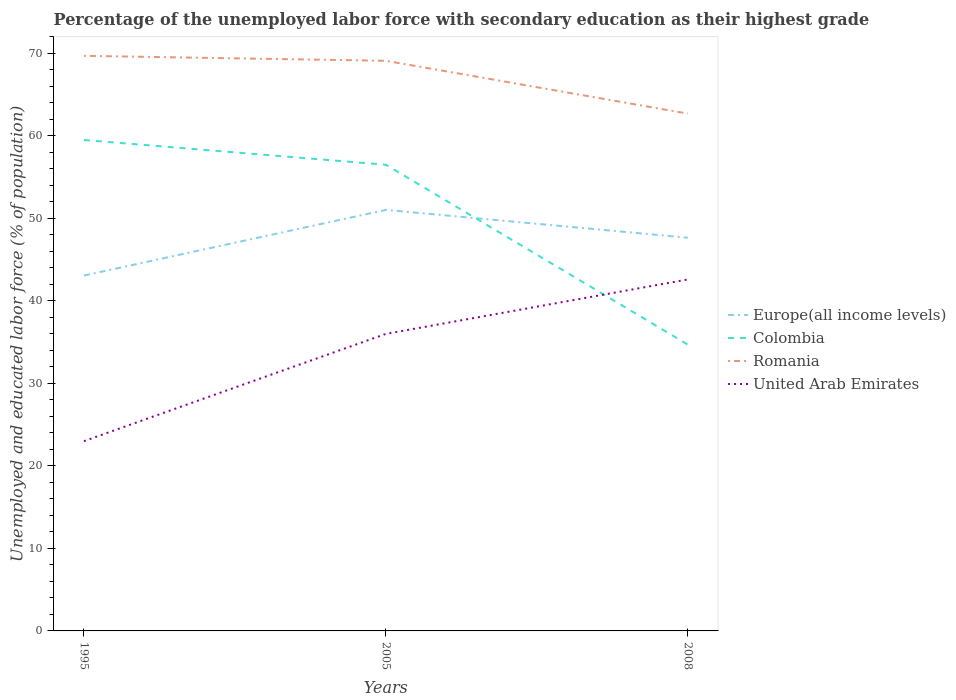How many different coloured lines are there?
Offer a very short reply. 4. Across all years, what is the maximum percentage of the unemployed labor force with secondary education in Romania?
Keep it short and to the point. 62.7. What is the total percentage of the unemployed labor force with secondary education in Colombia in the graph?
Your answer should be compact. 24.8. What is the difference between the highest and the second highest percentage of the unemployed labor force with secondary education in Romania?
Ensure brevity in your answer.  7. What is the difference between the highest and the lowest percentage of the unemployed labor force with secondary education in Colombia?
Your response must be concise. 2. Is the percentage of the unemployed labor force with secondary education in Europe(all income levels) strictly greater than the percentage of the unemployed labor force with secondary education in Romania over the years?
Provide a short and direct response. Yes. How many lines are there?
Provide a succinct answer. 4. How many years are there in the graph?
Ensure brevity in your answer.  3. Are the values on the major ticks of Y-axis written in scientific E-notation?
Give a very brief answer. No. Does the graph contain grids?
Your answer should be very brief. No. How many legend labels are there?
Make the answer very short. 4. What is the title of the graph?
Provide a succinct answer. Percentage of the unemployed labor force with secondary education as their highest grade. What is the label or title of the Y-axis?
Offer a very short reply. Unemployed and educated labor force (% of population). What is the Unemployed and educated labor force (% of population) in Europe(all income levels) in 1995?
Your response must be concise. 43.07. What is the Unemployed and educated labor force (% of population) of Colombia in 1995?
Provide a succinct answer. 59.5. What is the Unemployed and educated labor force (% of population) of Romania in 1995?
Your response must be concise. 69.7. What is the Unemployed and educated labor force (% of population) in Europe(all income levels) in 2005?
Make the answer very short. 51.03. What is the Unemployed and educated labor force (% of population) in Colombia in 2005?
Ensure brevity in your answer.  56.5. What is the Unemployed and educated labor force (% of population) of Romania in 2005?
Your answer should be very brief. 69.1. What is the Unemployed and educated labor force (% of population) of United Arab Emirates in 2005?
Offer a very short reply. 36. What is the Unemployed and educated labor force (% of population) of Europe(all income levels) in 2008?
Provide a short and direct response. 47.66. What is the Unemployed and educated labor force (% of population) of Colombia in 2008?
Your response must be concise. 34.7. What is the Unemployed and educated labor force (% of population) of Romania in 2008?
Provide a succinct answer. 62.7. What is the Unemployed and educated labor force (% of population) in United Arab Emirates in 2008?
Give a very brief answer. 42.6. Across all years, what is the maximum Unemployed and educated labor force (% of population) in Europe(all income levels)?
Ensure brevity in your answer.  51.03. Across all years, what is the maximum Unemployed and educated labor force (% of population) in Colombia?
Make the answer very short. 59.5. Across all years, what is the maximum Unemployed and educated labor force (% of population) in Romania?
Provide a short and direct response. 69.7. Across all years, what is the maximum Unemployed and educated labor force (% of population) in United Arab Emirates?
Offer a very short reply. 42.6. Across all years, what is the minimum Unemployed and educated labor force (% of population) in Europe(all income levels)?
Your answer should be compact. 43.07. Across all years, what is the minimum Unemployed and educated labor force (% of population) of Colombia?
Your response must be concise. 34.7. Across all years, what is the minimum Unemployed and educated labor force (% of population) in Romania?
Provide a succinct answer. 62.7. What is the total Unemployed and educated labor force (% of population) of Europe(all income levels) in the graph?
Make the answer very short. 141.76. What is the total Unemployed and educated labor force (% of population) of Colombia in the graph?
Your answer should be compact. 150.7. What is the total Unemployed and educated labor force (% of population) of Romania in the graph?
Keep it short and to the point. 201.5. What is the total Unemployed and educated labor force (% of population) of United Arab Emirates in the graph?
Keep it short and to the point. 101.6. What is the difference between the Unemployed and educated labor force (% of population) of Europe(all income levels) in 1995 and that in 2005?
Your answer should be compact. -7.95. What is the difference between the Unemployed and educated labor force (% of population) in Europe(all income levels) in 1995 and that in 2008?
Ensure brevity in your answer.  -4.58. What is the difference between the Unemployed and educated labor force (% of population) of Colombia in 1995 and that in 2008?
Keep it short and to the point. 24.8. What is the difference between the Unemployed and educated labor force (% of population) of United Arab Emirates in 1995 and that in 2008?
Give a very brief answer. -19.6. What is the difference between the Unemployed and educated labor force (% of population) in Europe(all income levels) in 2005 and that in 2008?
Keep it short and to the point. 3.37. What is the difference between the Unemployed and educated labor force (% of population) in Colombia in 2005 and that in 2008?
Ensure brevity in your answer.  21.8. What is the difference between the Unemployed and educated labor force (% of population) of Romania in 2005 and that in 2008?
Keep it short and to the point. 6.4. What is the difference between the Unemployed and educated labor force (% of population) in United Arab Emirates in 2005 and that in 2008?
Ensure brevity in your answer.  -6.6. What is the difference between the Unemployed and educated labor force (% of population) in Europe(all income levels) in 1995 and the Unemployed and educated labor force (% of population) in Colombia in 2005?
Ensure brevity in your answer.  -13.43. What is the difference between the Unemployed and educated labor force (% of population) in Europe(all income levels) in 1995 and the Unemployed and educated labor force (% of population) in Romania in 2005?
Offer a very short reply. -26.03. What is the difference between the Unemployed and educated labor force (% of population) in Europe(all income levels) in 1995 and the Unemployed and educated labor force (% of population) in United Arab Emirates in 2005?
Your answer should be very brief. 7.07. What is the difference between the Unemployed and educated labor force (% of population) in Colombia in 1995 and the Unemployed and educated labor force (% of population) in United Arab Emirates in 2005?
Provide a succinct answer. 23.5. What is the difference between the Unemployed and educated labor force (% of population) of Romania in 1995 and the Unemployed and educated labor force (% of population) of United Arab Emirates in 2005?
Give a very brief answer. 33.7. What is the difference between the Unemployed and educated labor force (% of population) in Europe(all income levels) in 1995 and the Unemployed and educated labor force (% of population) in Colombia in 2008?
Provide a short and direct response. 8.37. What is the difference between the Unemployed and educated labor force (% of population) of Europe(all income levels) in 1995 and the Unemployed and educated labor force (% of population) of Romania in 2008?
Ensure brevity in your answer.  -19.63. What is the difference between the Unemployed and educated labor force (% of population) in Europe(all income levels) in 1995 and the Unemployed and educated labor force (% of population) in United Arab Emirates in 2008?
Ensure brevity in your answer.  0.47. What is the difference between the Unemployed and educated labor force (% of population) of Colombia in 1995 and the Unemployed and educated labor force (% of population) of Romania in 2008?
Your answer should be compact. -3.2. What is the difference between the Unemployed and educated labor force (% of population) of Colombia in 1995 and the Unemployed and educated labor force (% of population) of United Arab Emirates in 2008?
Provide a short and direct response. 16.9. What is the difference between the Unemployed and educated labor force (% of population) of Romania in 1995 and the Unemployed and educated labor force (% of population) of United Arab Emirates in 2008?
Ensure brevity in your answer.  27.1. What is the difference between the Unemployed and educated labor force (% of population) of Europe(all income levels) in 2005 and the Unemployed and educated labor force (% of population) of Colombia in 2008?
Provide a succinct answer. 16.33. What is the difference between the Unemployed and educated labor force (% of population) in Europe(all income levels) in 2005 and the Unemployed and educated labor force (% of population) in Romania in 2008?
Your answer should be very brief. -11.67. What is the difference between the Unemployed and educated labor force (% of population) of Europe(all income levels) in 2005 and the Unemployed and educated labor force (% of population) of United Arab Emirates in 2008?
Offer a terse response. 8.43. What is the difference between the Unemployed and educated labor force (% of population) of Colombia in 2005 and the Unemployed and educated labor force (% of population) of United Arab Emirates in 2008?
Your response must be concise. 13.9. What is the difference between the Unemployed and educated labor force (% of population) of Romania in 2005 and the Unemployed and educated labor force (% of population) of United Arab Emirates in 2008?
Ensure brevity in your answer.  26.5. What is the average Unemployed and educated labor force (% of population) of Europe(all income levels) per year?
Provide a short and direct response. 47.25. What is the average Unemployed and educated labor force (% of population) of Colombia per year?
Your answer should be compact. 50.23. What is the average Unemployed and educated labor force (% of population) in Romania per year?
Ensure brevity in your answer.  67.17. What is the average Unemployed and educated labor force (% of population) in United Arab Emirates per year?
Give a very brief answer. 33.87. In the year 1995, what is the difference between the Unemployed and educated labor force (% of population) in Europe(all income levels) and Unemployed and educated labor force (% of population) in Colombia?
Ensure brevity in your answer.  -16.43. In the year 1995, what is the difference between the Unemployed and educated labor force (% of population) in Europe(all income levels) and Unemployed and educated labor force (% of population) in Romania?
Provide a succinct answer. -26.63. In the year 1995, what is the difference between the Unemployed and educated labor force (% of population) of Europe(all income levels) and Unemployed and educated labor force (% of population) of United Arab Emirates?
Your response must be concise. 20.07. In the year 1995, what is the difference between the Unemployed and educated labor force (% of population) of Colombia and Unemployed and educated labor force (% of population) of Romania?
Give a very brief answer. -10.2. In the year 1995, what is the difference between the Unemployed and educated labor force (% of population) of Colombia and Unemployed and educated labor force (% of population) of United Arab Emirates?
Keep it short and to the point. 36.5. In the year 1995, what is the difference between the Unemployed and educated labor force (% of population) of Romania and Unemployed and educated labor force (% of population) of United Arab Emirates?
Your answer should be very brief. 46.7. In the year 2005, what is the difference between the Unemployed and educated labor force (% of population) in Europe(all income levels) and Unemployed and educated labor force (% of population) in Colombia?
Your answer should be very brief. -5.47. In the year 2005, what is the difference between the Unemployed and educated labor force (% of population) in Europe(all income levels) and Unemployed and educated labor force (% of population) in Romania?
Give a very brief answer. -18.07. In the year 2005, what is the difference between the Unemployed and educated labor force (% of population) in Europe(all income levels) and Unemployed and educated labor force (% of population) in United Arab Emirates?
Offer a terse response. 15.03. In the year 2005, what is the difference between the Unemployed and educated labor force (% of population) in Colombia and Unemployed and educated labor force (% of population) in Romania?
Ensure brevity in your answer.  -12.6. In the year 2005, what is the difference between the Unemployed and educated labor force (% of population) in Colombia and Unemployed and educated labor force (% of population) in United Arab Emirates?
Offer a terse response. 20.5. In the year 2005, what is the difference between the Unemployed and educated labor force (% of population) in Romania and Unemployed and educated labor force (% of population) in United Arab Emirates?
Make the answer very short. 33.1. In the year 2008, what is the difference between the Unemployed and educated labor force (% of population) in Europe(all income levels) and Unemployed and educated labor force (% of population) in Colombia?
Ensure brevity in your answer.  12.96. In the year 2008, what is the difference between the Unemployed and educated labor force (% of population) of Europe(all income levels) and Unemployed and educated labor force (% of population) of Romania?
Offer a terse response. -15.04. In the year 2008, what is the difference between the Unemployed and educated labor force (% of population) of Europe(all income levels) and Unemployed and educated labor force (% of population) of United Arab Emirates?
Keep it short and to the point. 5.06. In the year 2008, what is the difference between the Unemployed and educated labor force (% of population) of Colombia and Unemployed and educated labor force (% of population) of Romania?
Provide a succinct answer. -28. In the year 2008, what is the difference between the Unemployed and educated labor force (% of population) in Romania and Unemployed and educated labor force (% of population) in United Arab Emirates?
Provide a succinct answer. 20.1. What is the ratio of the Unemployed and educated labor force (% of population) of Europe(all income levels) in 1995 to that in 2005?
Your answer should be very brief. 0.84. What is the ratio of the Unemployed and educated labor force (% of population) in Colombia in 1995 to that in 2005?
Ensure brevity in your answer.  1.05. What is the ratio of the Unemployed and educated labor force (% of population) in Romania in 1995 to that in 2005?
Ensure brevity in your answer.  1.01. What is the ratio of the Unemployed and educated labor force (% of population) in United Arab Emirates in 1995 to that in 2005?
Your answer should be very brief. 0.64. What is the ratio of the Unemployed and educated labor force (% of population) of Europe(all income levels) in 1995 to that in 2008?
Your answer should be very brief. 0.9. What is the ratio of the Unemployed and educated labor force (% of population) in Colombia in 1995 to that in 2008?
Give a very brief answer. 1.71. What is the ratio of the Unemployed and educated labor force (% of population) of Romania in 1995 to that in 2008?
Give a very brief answer. 1.11. What is the ratio of the Unemployed and educated labor force (% of population) of United Arab Emirates in 1995 to that in 2008?
Ensure brevity in your answer.  0.54. What is the ratio of the Unemployed and educated labor force (% of population) of Europe(all income levels) in 2005 to that in 2008?
Give a very brief answer. 1.07. What is the ratio of the Unemployed and educated labor force (% of population) in Colombia in 2005 to that in 2008?
Give a very brief answer. 1.63. What is the ratio of the Unemployed and educated labor force (% of population) in Romania in 2005 to that in 2008?
Offer a very short reply. 1.1. What is the ratio of the Unemployed and educated labor force (% of population) in United Arab Emirates in 2005 to that in 2008?
Offer a very short reply. 0.85. What is the difference between the highest and the second highest Unemployed and educated labor force (% of population) of Europe(all income levels)?
Provide a succinct answer. 3.37. What is the difference between the highest and the second highest Unemployed and educated labor force (% of population) of Colombia?
Offer a very short reply. 3. What is the difference between the highest and the second highest Unemployed and educated labor force (% of population) in United Arab Emirates?
Your answer should be very brief. 6.6. What is the difference between the highest and the lowest Unemployed and educated labor force (% of population) of Europe(all income levels)?
Provide a short and direct response. 7.95. What is the difference between the highest and the lowest Unemployed and educated labor force (% of population) of Colombia?
Your response must be concise. 24.8. What is the difference between the highest and the lowest Unemployed and educated labor force (% of population) of United Arab Emirates?
Offer a very short reply. 19.6. 